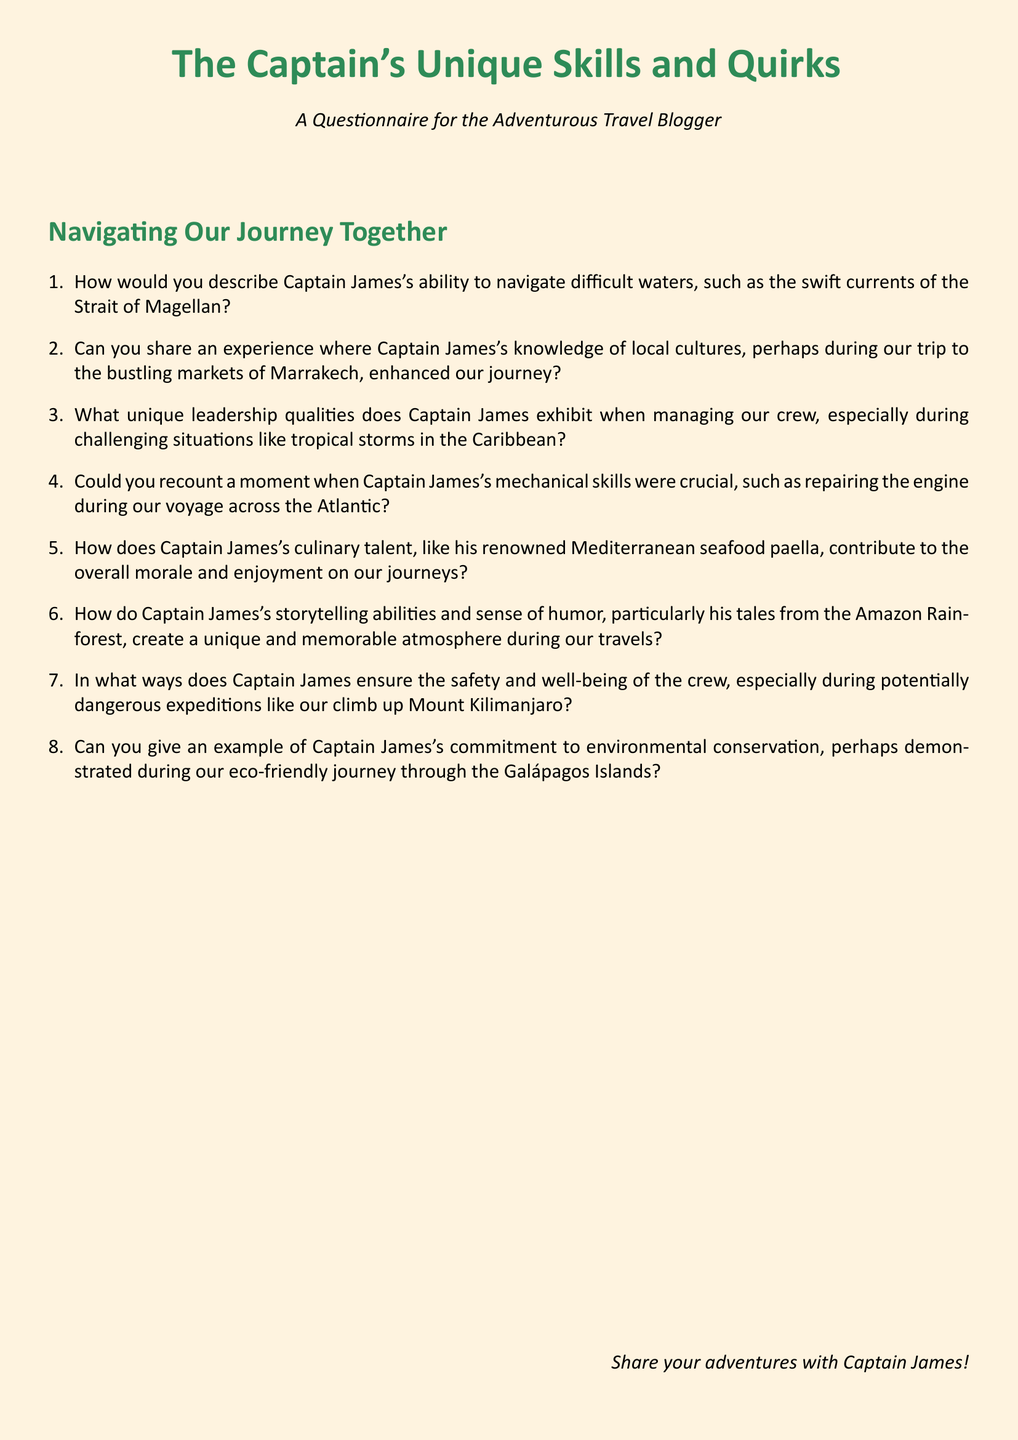How many questions are in the questionnaire? The number of questions is indicated by the enumerated list in the document.
Answer: 8 What is the primary color used for the section titles? The primary color is specified in the document using the definecolor command.
Answer: seagreen Which location is mentioned for Captain James's mechanical skills? The document provides a specific location associated with the experience shared about Captain James's mechanical skills.
Answer: Atlantic What is Captain James's renowned culinary talent? The document describes a specific dish that highlights Captain James's culinary skill.
Answer: Mediterranean seafood paella What unique skill of Captain James is mentioned in relation to Mount Kilimanjaro? The document references specific skills related to safety during the expedition.
Answer: Safety and well-being What type of atmosphere does Captain James create during travels? The document mentions specific attributes of Captain James that contribute to the overall atmosphere during trips.
Answer: Unique and memorable What is the environmental conservation example related to? The document discusses a specific journey that illustrates Captain James's commitment to conservation.
Answer: Galápagos Islands Which market experience is mentioned in the document? The document highlights a specific location where Captain James's knowledge enriched the journey.
Answer: Marrakech 